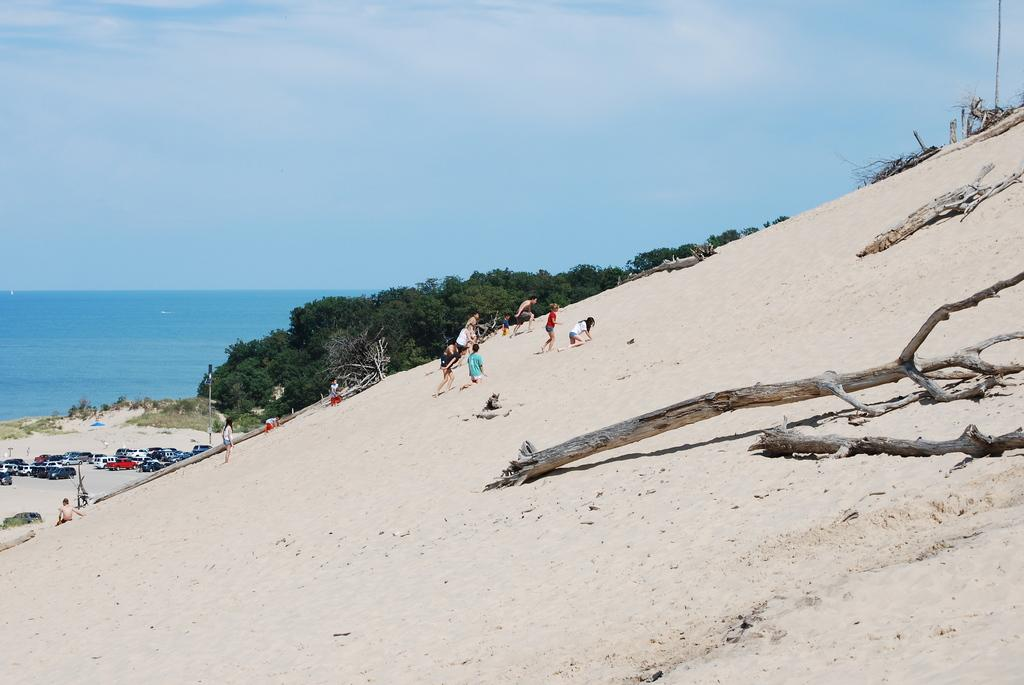Who or what can be seen in the image? There are people in the image. What is the ground made of in the image? Tree trunks are present on the sand floor. What body of water is visible in the image? There is a sea visible in the image. What type of vehicles are in the image? There are cars in the image. What type of vegetation is present in the image? Trees are present in the image. What type of yoke is being used by the people in the image? There is no yoke present in the image. What government policies are being discussed by the people in the image? There is no indication of any government policies being discussed in the image. 